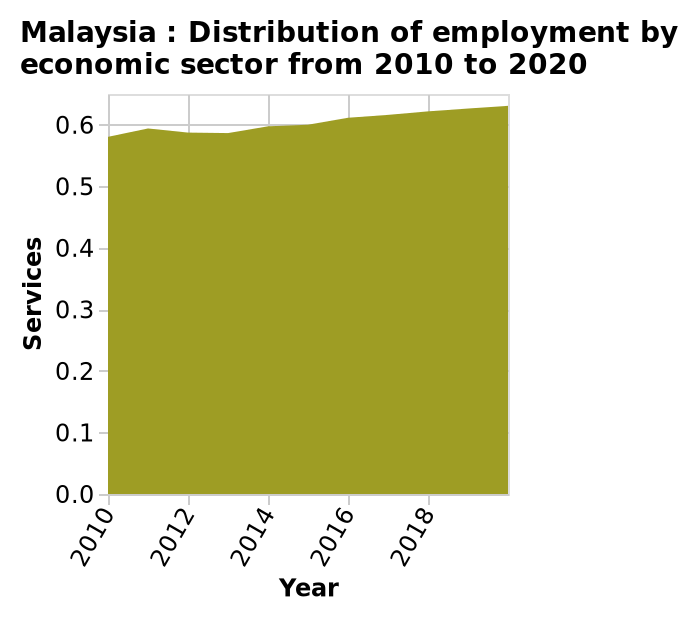<image>
What is the percentage increase in employment from 2010 to 2018? The percentage increase in employment is less than 0.1%. What is the trend in employment between 2010 and 2018?  There is a small gradual incline in employment. please describe the details of the chart This is a area diagram labeled Malaysia : Distribution of employment by economic sector from 2010 to 2020. There is a linear scale with a minimum of 2010 and a maximum of 2018 along the x-axis, labeled Year. A scale of range 0.0 to 0.6 can be seen along the y-axis, marked Services. What is the area diagram in Malaysia labeled as?  The area diagram in Malaysia is labeled as the "Distribution of employment by economic sector from 2010 to 2020". What is the minimum and maximum value shown on the x-axis? The minimum value on the x-axis is 2010 and the maximum value is 2020. What is the range of values on the y-axis in the area diagram of Malaysia?  The range of values on the y-axis is from 0.0 to 0.6. 